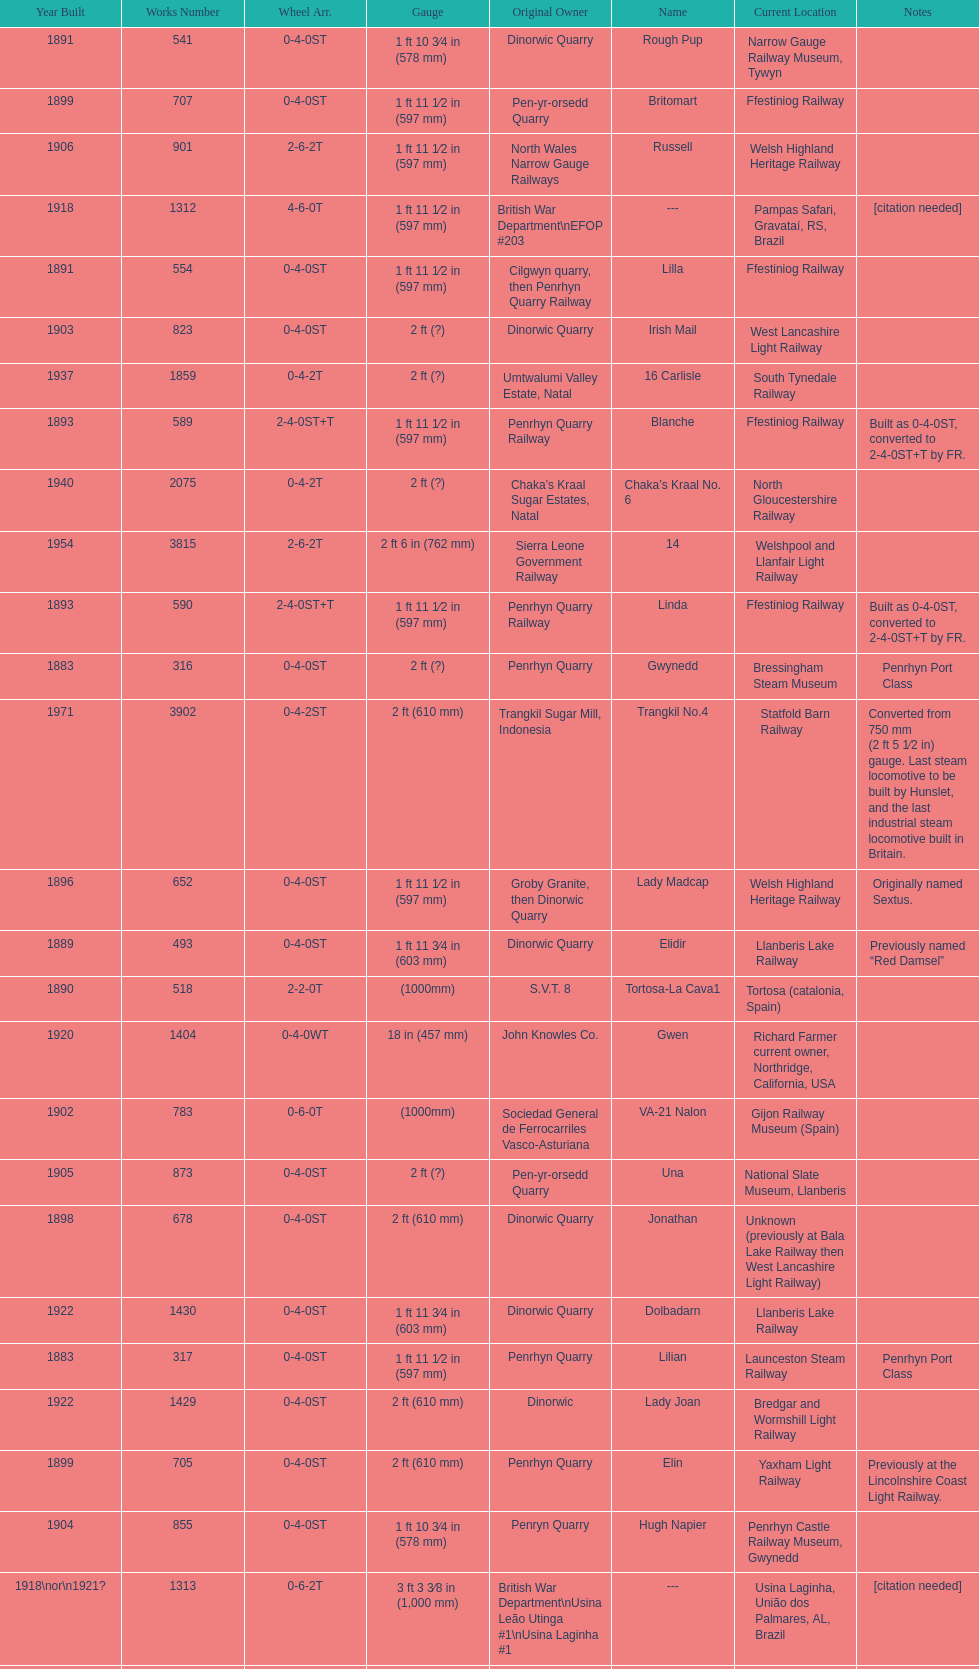Which original owner had the most locomotives? Penrhyn Quarry. 